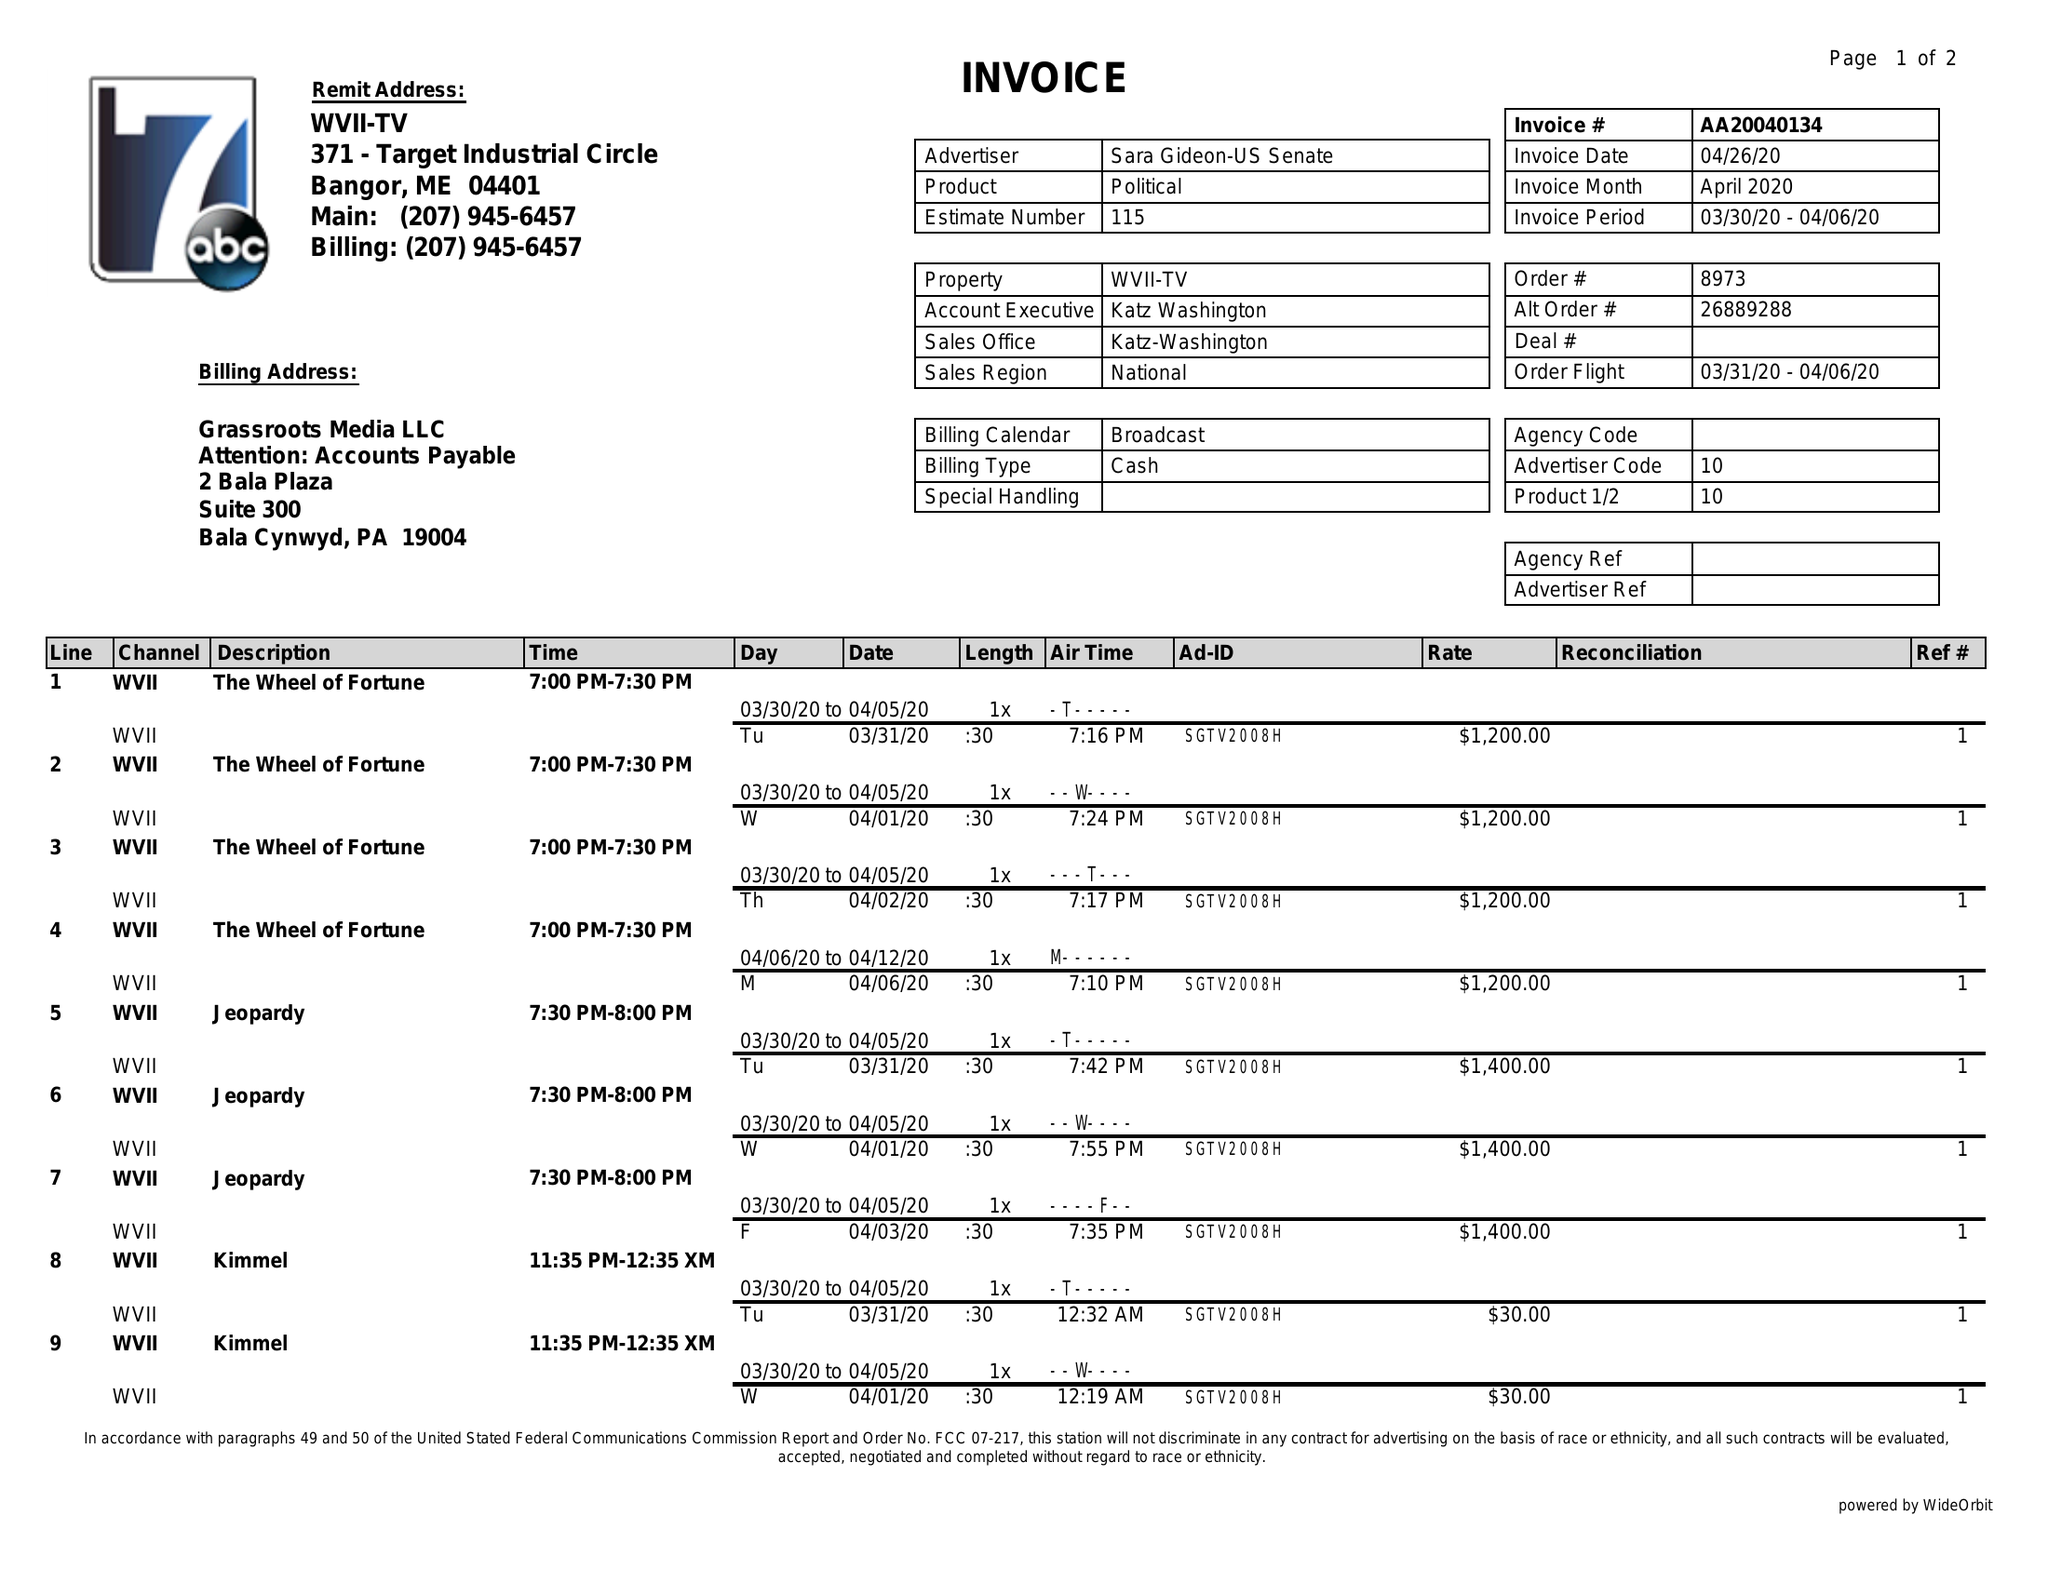What is the value for the flight_to?
Answer the question using a single word or phrase. 04/06/20 